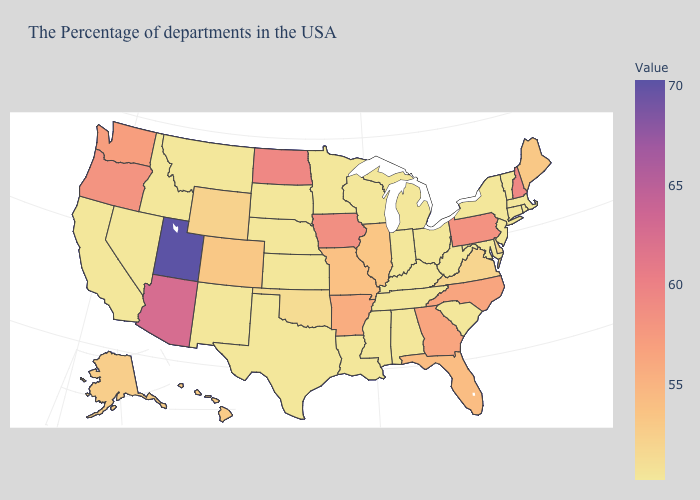Does Illinois have the lowest value in the MidWest?
Be succinct. No. Among the states that border California , which have the highest value?
Concise answer only. Arizona. 